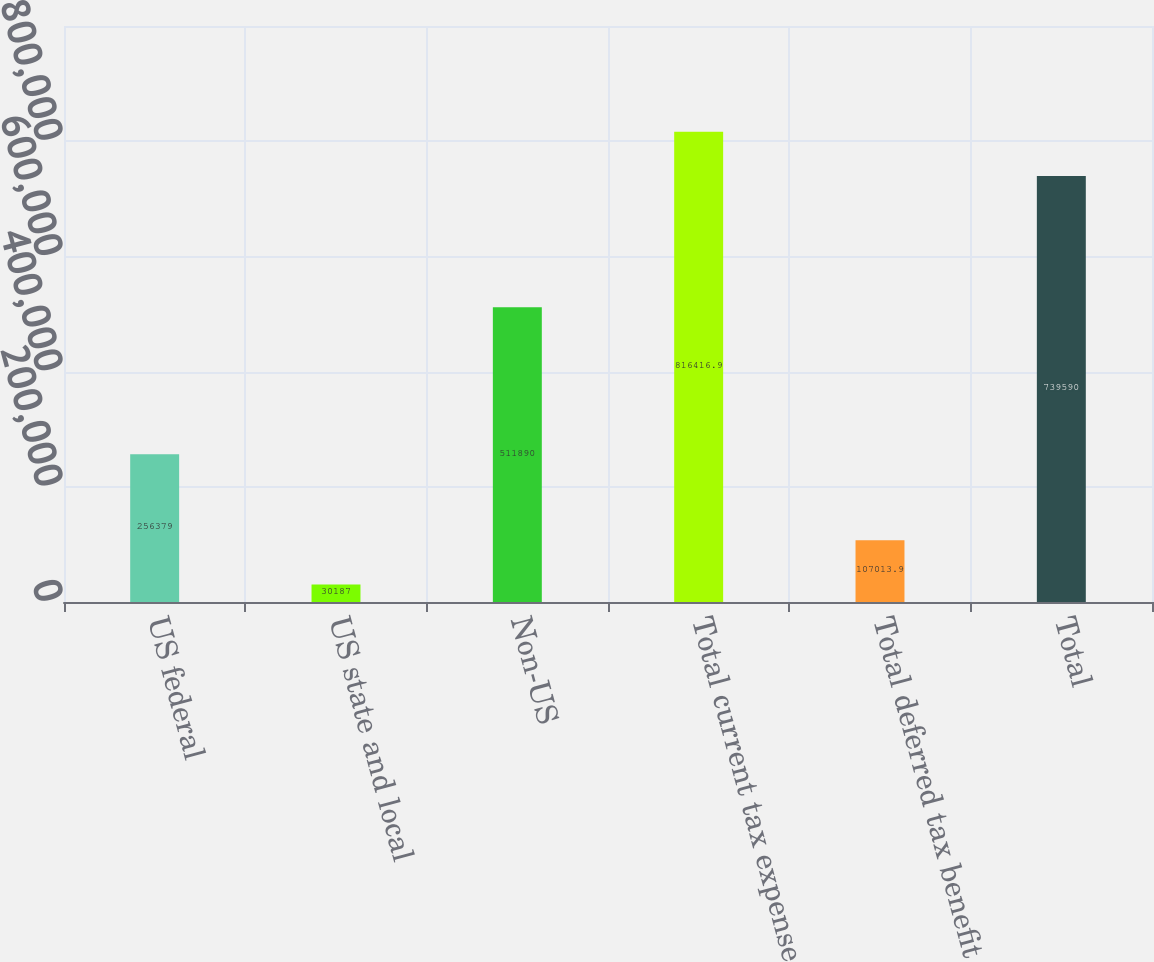<chart> <loc_0><loc_0><loc_500><loc_500><bar_chart><fcel>US federal<fcel>US state and local<fcel>Non-US<fcel>Total current tax expense<fcel>Total deferred tax benefit<fcel>Total<nl><fcel>256379<fcel>30187<fcel>511890<fcel>816417<fcel>107014<fcel>739590<nl></chart> 